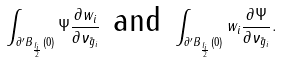Convert formula to latex. <formula><loc_0><loc_0><loc_500><loc_500>\int _ { \partial ^ { \prime } B _ { \frac { l _ { i } } { 2 } } ( 0 ) } \Psi \frac { \partial w _ { i } } { \partial \nu _ { \tilde { g } _ { i } } } \text { and } \int _ { \partial ^ { \prime } B _ { \frac { l _ { i } } { 2 } } ( 0 ) } w _ { i } \frac { \partial \Psi } { \partial \nu _ { \tilde { g } _ { i } } } .</formula> 